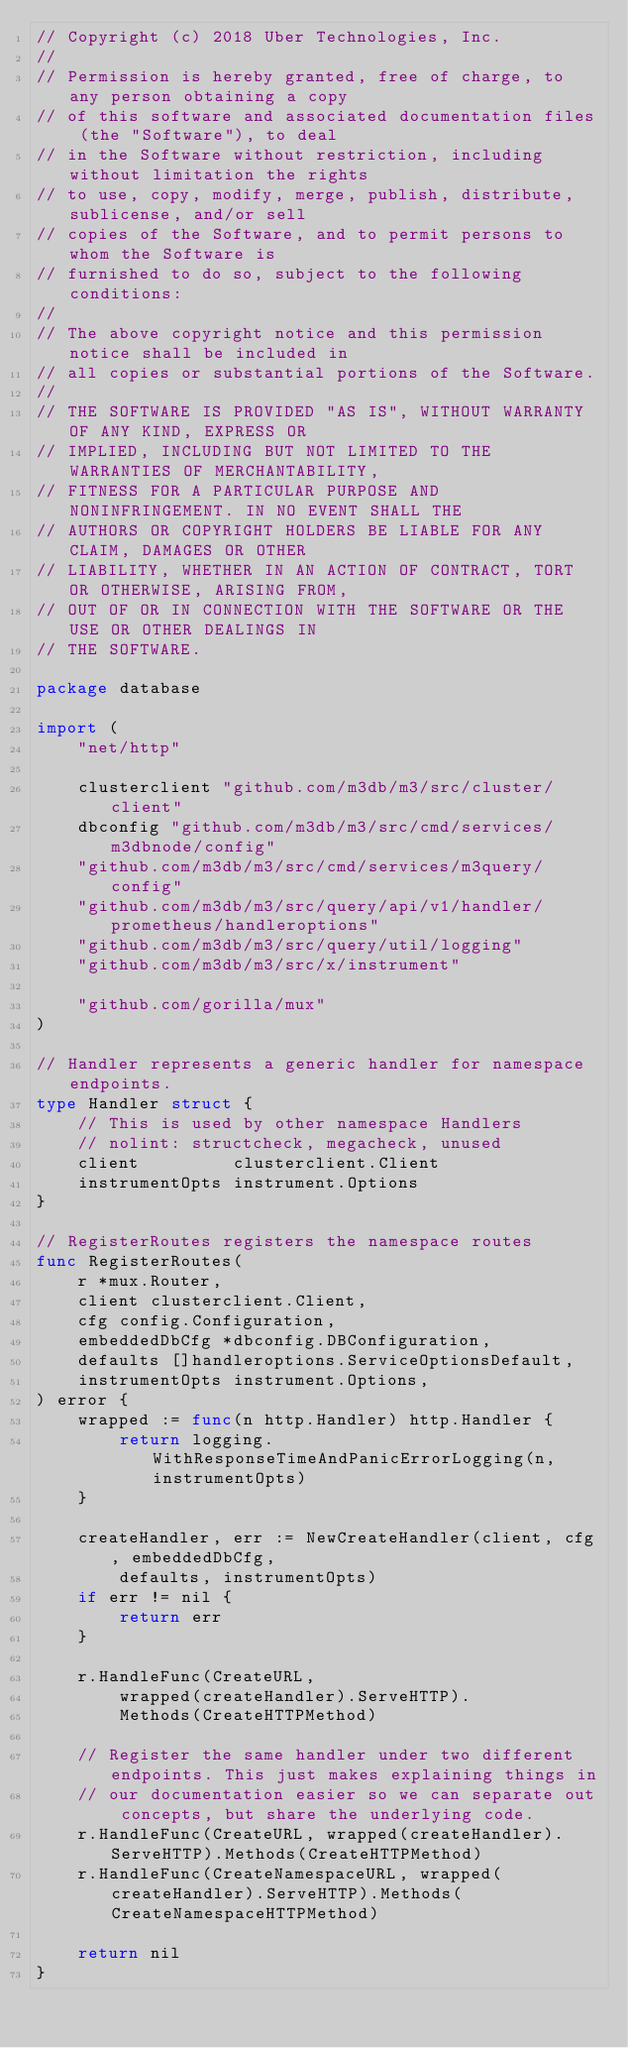Convert code to text. <code><loc_0><loc_0><loc_500><loc_500><_Go_>// Copyright (c) 2018 Uber Technologies, Inc.
//
// Permission is hereby granted, free of charge, to any person obtaining a copy
// of this software and associated documentation files (the "Software"), to deal
// in the Software without restriction, including without limitation the rights
// to use, copy, modify, merge, publish, distribute, sublicense, and/or sell
// copies of the Software, and to permit persons to whom the Software is
// furnished to do so, subject to the following conditions:
//
// The above copyright notice and this permission notice shall be included in
// all copies or substantial portions of the Software.
//
// THE SOFTWARE IS PROVIDED "AS IS", WITHOUT WARRANTY OF ANY KIND, EXPRESS OR
// IMPLIED, INCLUDING BUT NOT LIMITED TO THE WARRANTIES OF MERCHANTABILITY,
// FITNESS FOR A PARTICULAR PURPOSE AND NONINFRINGEMENT. IN NO EVENT SHALL THE
// AUTHORS OR COPYRIGHT HOLDERS BE LIABLE FOR ANY CLAIM, DAMAGES OR OTHER
// LIABILITY, WHETHER IN AN ACTION OF CONTRACT, TORT OR OTHERWISE, ARISING FROM,
// OUT OF OR IN CONNECTION WITH THE SOFTWARE OR THE USE OR OTHER DEALINGS IN
// THE SOFTWARE.

package database

import (
	"net/http"

	clusterclient "github.com/m3db/m3/src/cluster/client"
	dbconfig "github.com/m3db/m3/src/cmd/services/m3dbnode/config"
	"github.com/m3db/m3/src/cmd/services/m3query/config"
	"github.com/m3db/m3/src/query/api/v1/handler/prometheus/handleroptions"
	"github.com/m3db/m3/src/query/util/logging"
	"github.com/m3db/m3/src/x/instrument"

	"github.com/gorilla/mux"
)

// Handler represents a generic handler for namespace endpoints.
type Handler struct {
	// This is used by other namespace Handlers
	// nolint: structcheck, megacheck, unused
	client         clusterclient.Client
	instrumentOpts instrument.Options
}

// RegisterRoutes registers the namespace routes
func RegisterRoutes(
	r *mux.Router,
	client clusterclient.Client,
	cfg config.Configuration,
	embeddedDbCfg *dbconfig.DBConfiguration,
	defaults []handleroptions.ServiceOptionsDefault,
	instrumentOpts instrument.Options,
) error {
	wrapped := func(n http.Handler) http.Handler {
		return logging.WithResponseTimeAndPanicErrorLogging(n, instrumentOpts)
	}

	createHandler, err := NewCreateHandler(client, cfg, embeddedDbCfg,
		defaults, instrumentOpts)
	if err != nil {
		return err
	}

	r.HandleFunc(CreateURL,
		wrapped(createHandler).ServeHTTP).
		Methods(CreateHTTPMethod)

	// Register the same handler under two different endpoints. This just makes explaining things in
	// our documentation easier so we can separate out concepts, but share the underlying code.
	r.HandleFunc(CreateURL, wrapped(createHandler).ServeHTTP).Methods(CreateHTTPMethod)
	r.HandleFunc(CreateNamespaceURL, wrapped(createHandler).ServeHTTP).Methods(CreateNamespaceHTTPMethod)

	return nil
}
</code> 